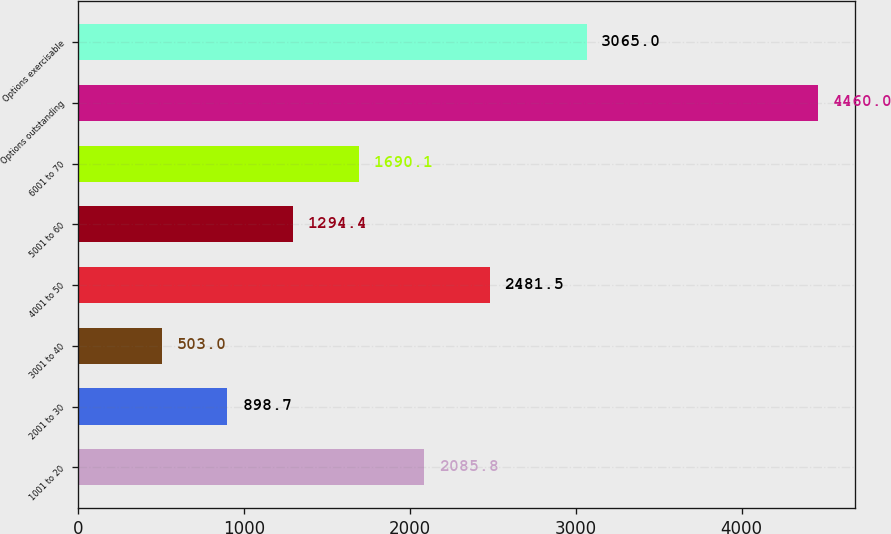Convert chart to OTSL. <chart><loc_0><loc_0><loc_500><loc_500><bar_chart><fcel>1001 to 20<fcel>2001 to 30<fcel>3001 to 40<fcel>4001 to 50<fcel>5001 to 60<fcel>6001 to 70<fcel>Options outstanding<fcel>Options exercisable<nl><fcel>2085.8<fcel>898.7<fcel>503<fcel>2481.5<fcel>1294.4<fcel>1690.1<fcel>4460<fcel>3065<nl></chart> 